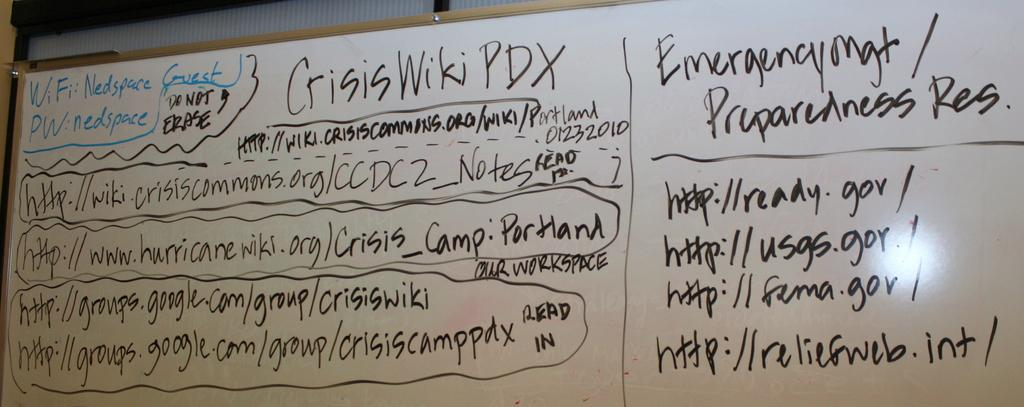<image>
Summarize the visual content of the image. Nedspace is the Guest WiFi and nedspace is the password. 